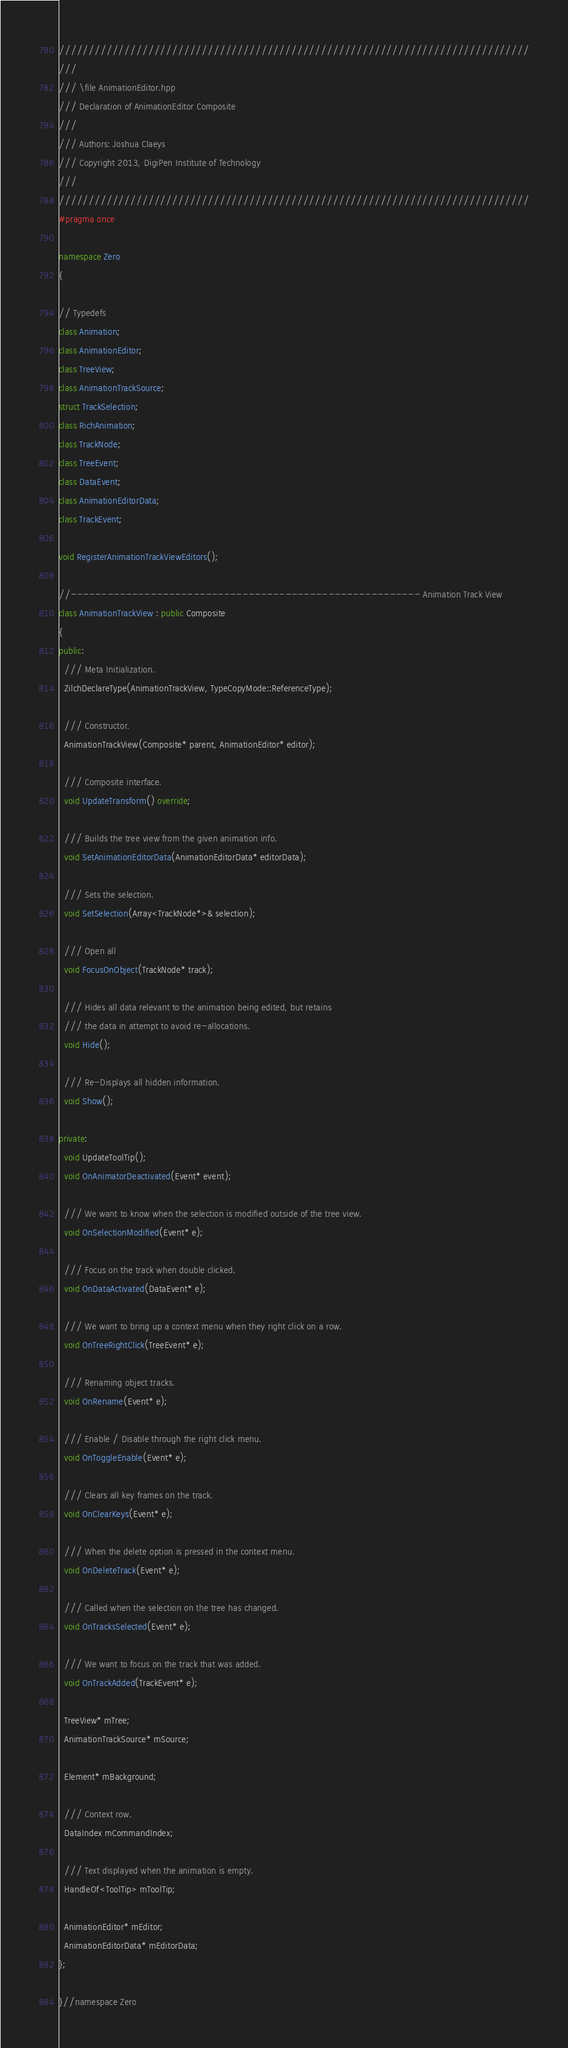Convert code to text. <code><loc_0><loc_0><loc_500><loc_500><_C++_>///////////////////////////////////////////////////////////////////////////////
///
/// \file AnimationEditor.hpp
/// Declaration of AnimationEditor Composite
///
/// Authors: Joshua Claeys
/// Copyright 2013, DigiPen Institute of Technology
///
///////////////////////////////////////////////////////////////////////////////
#pragma once

namespace Zero
{

// Typedefs
class Animation;
class AnimationEditor;
class TreeView;
class AnimationTrackSource;
struct TrackSelection;
class RichAnimation;
class TrackNode;
class TreeEvent;
class DataEvent;
class AnimationEditorData;
class TrackEvent;

void RegisterAnimationTrackViewEditors();

//--------------------------------------------------------- Animation Track View
class AnimationTrackView : public Composite
{
public:
  /// Meta Initialization.
  ZilchDeclareType(AnimationTrackView, TypeCopyMode::ReferenceType);

  /// Constructor.
  AnimationTrackView(Composite* parent, AnimationEditor* editor);

  /// Composite interface.
  void UpdateTransform() override;

  /// Builds the tree view from the given animation info.
  void SetAnimationEditorData(AnimationEditorData* editorData);

  /// Sets the selection.
  void SetSelection(Array<TrackNode*>& selection);

  /// Open all
  void FocusOnObject(TrackNode* track);

  /// Hides all data relevant to the animation being edited, but retains
  /// the data in attempt to avoid re-allocations.
  void Hide();

  /// Re-Displays all hidden information.
  void Show();

private:
  void UpdateToolTip();
  void OnAnimatorDeactivated(Event* event);

  /// We want to know when the selection is modified outside of the tree view.
  void OnSelectionModified(Event* e);

  /// Focus on the track when double clicked.
  void OnDataActivated(DataEvent* e);

  /// We want to bring up a context menu when they right click on a row.
  void OnTreeRightClick(TreeEvent* e);

  /// Renaming object tracks.
  void OnRename(Event* e);

  /// Enable / Disable through the right click menu.
  void OnToggleEnable(Event* e);

  /// Clears all key frames on the track.
  void OnClearKeys(Event* e);

  /// When the delete option is pressed in the context menu.
  void OnDeleteTrack(Event* e);

  /// Called when the selection on the tree has changed.
  void OnTracksSelected(Event* e);

  /// We want to focus on the track that was added.
  void OnTrackAdded(TrackEvent* e);

  TreeView* mTree;
  AnimationTrackSource* mSource;

  Element* mBackground;

  /// Context row.
  DataIndex mCommandIndex;

  /// Text displayed when the animation is empty.
  HandleOf<ToolTip> mToolTip;

  AnimationEditor* mEditor;
  AnimationEditorData* mEditorData;
};

}//namespace Zero
</code> 